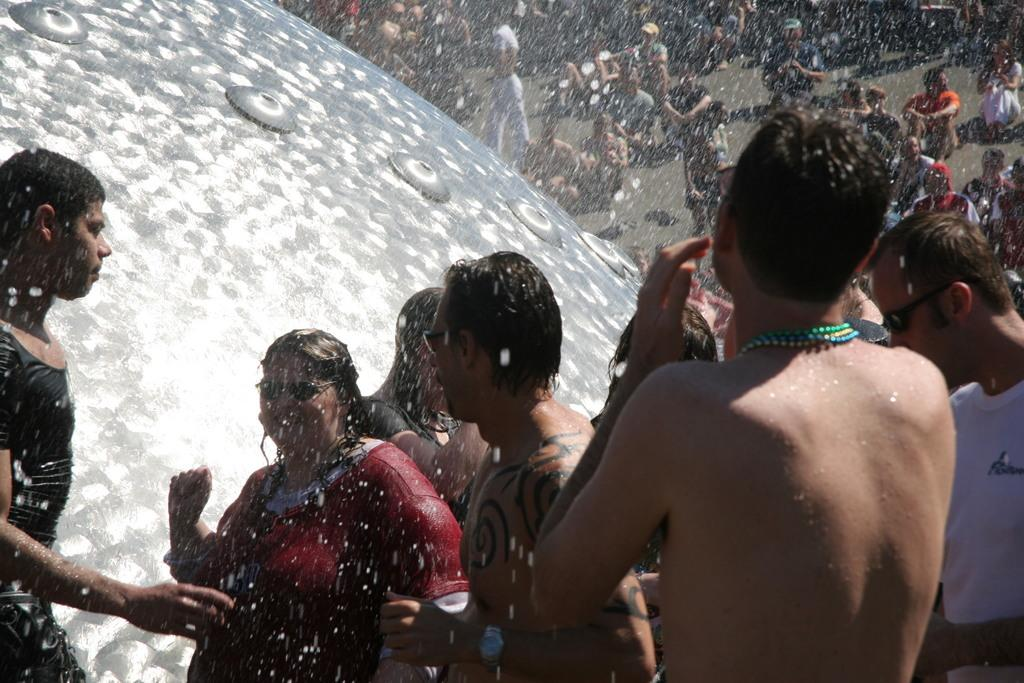What are the people in the image doing? There are people standing and seated on the ground in the image. What is the weather like in the image? It is snowing in the image. Can you describe the attire of some people in the image? Some people are wearing sunglasses in the image. What type of stamp can be seen on the bedroom wall in the image? There is no bedroom or stamp present in the image; it features people standing and seated on the ground in a snowy environment. 